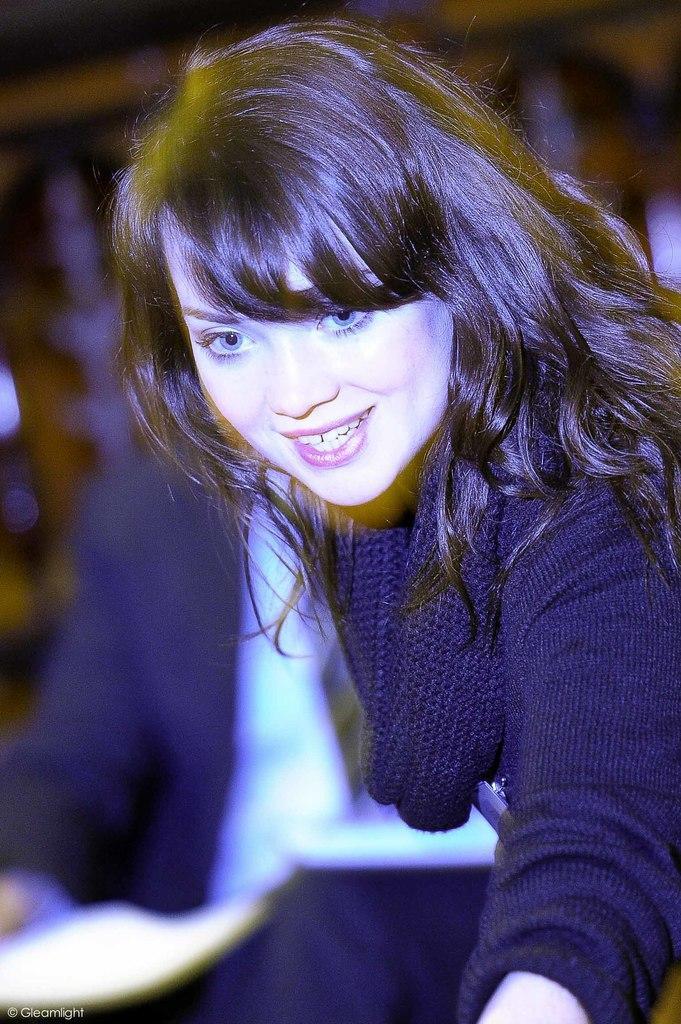How would you summarize this image in a sentence or two? This picture shows a woman with a smile on your face and we see a man seated on the side and women wore black color dress. 